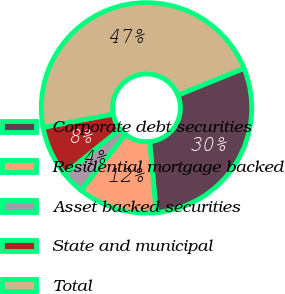<chart> <loc_0><loc_0><loc_500><loc_500><pie_chart><fcel>Corporate debt securities<fcel>Residential mortgage backed<fcel>Asset backed securities<fcel>State and municipal<fcel>Total<nl><fcel>29.65%<fcel>12.17%<fcel>3.51%<fcel>7.84%<fcel>46.82%<nl></chart> 